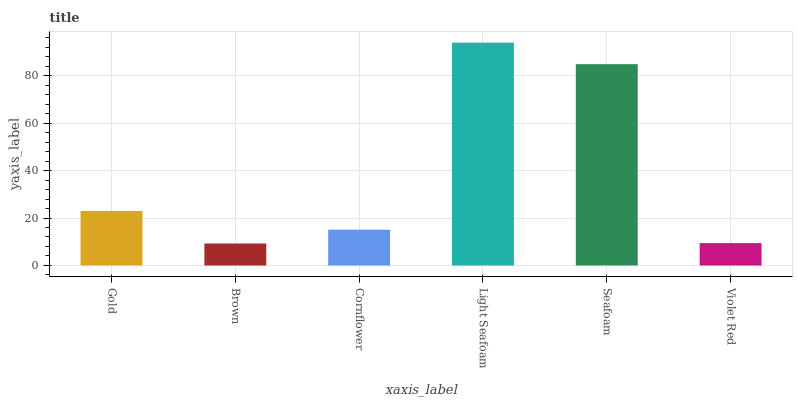Is Brown the minimum?
Answer yes or no. Yes. Is Light Seafoam the maximum?
Answer yes or no. Yes. Is Cornflower the minimum?
Answer yes or no. No. Is Cornflower the maximum?
Answer yes or no. No. Is Cornflower greater than Brown?
Answer yes or no. Yes. Is Brown less than Cornflower?
Answer yes or no. Yes. Is Brown greater than Cornflower?
Answer yes or no. No. Is Cornflower less than Brown?
Answer yes or no. No. Is Gold the high median?
Answer yes or no. Yes. Is Cornflower the low median?
Answer yes or no. Yes. Is Brown the high median?
Answer yes or no. No. Is Light Seafoam the low median?
Answer yes or no. No. 